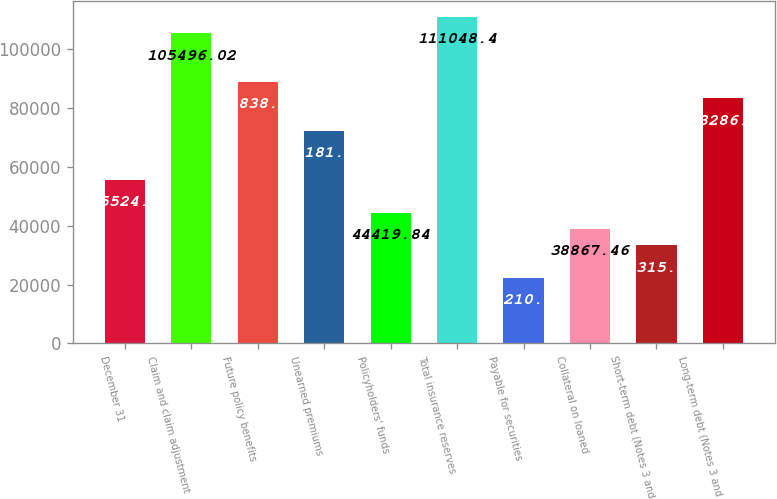<chart> <loc_0><loc_0><loc_500><loc_500><bar_chart><fcel>December 31<fcel>Claim and claim adjustment<fcel>Future policy benefits<fcel>Unearned premiums<fcel>Policyholders' funds<fcel>Total insurance reserves<fcel>Payable for securities<fcel>Collateral on loaned<fcel>Short-term debt (Notes 3 and<fcel>Long-term debt (Notes 3 and<nl><fcel>55524.6<fcel>105496<fcel>88838.9<fcel>72181.7<fcel>44419.8<fcel>111048<fcel>22210.3<fcel>38867.5<fcel>33315.1<fcel>83286.5<nl></chart> 